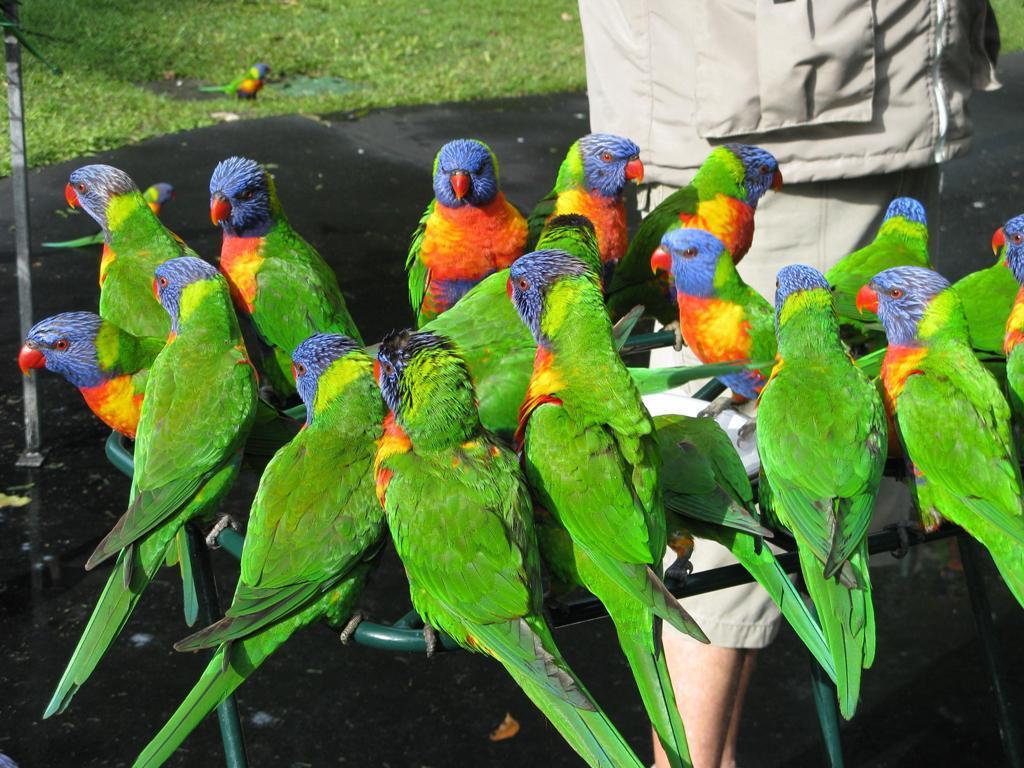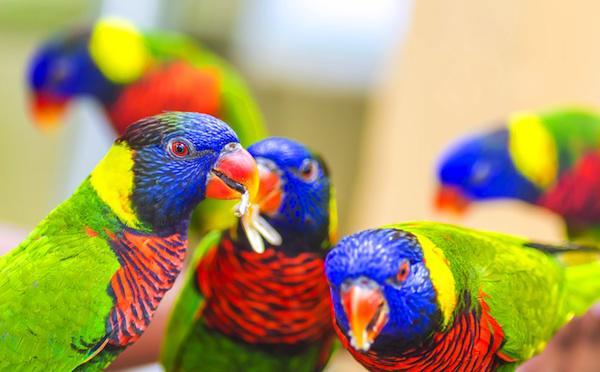The first image is the image on the left, the second image is the image on the right. Analyze the images presented: Is the assertion "There are lorikeets drinking from a silver, handheld bowl in the left image." valid? Answer yes or no. No. The first image is the image on the left, the second image is the image on the right. Evaluate the accuracy of this statement regarding the images: "Left image shows a hand holding a round pan from which multi-colored birds drink.". Is it true? Answer yes or no. No. 